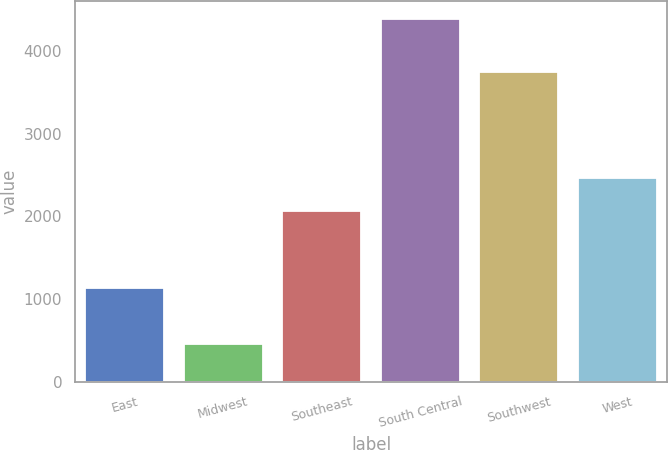Convert chart. <chart><loc_0><loc_0><loc_500><loc_500><bar_chart><fcel>East<fcel>Midwest<fcel>Southeast<fcel>South Central<fcel>Southwest<fcel>West<nl><fcel>1138<fcel>464<fcel>2069<fcel>4381<fcel>3742<fcel>2460.7<nl></chart> 